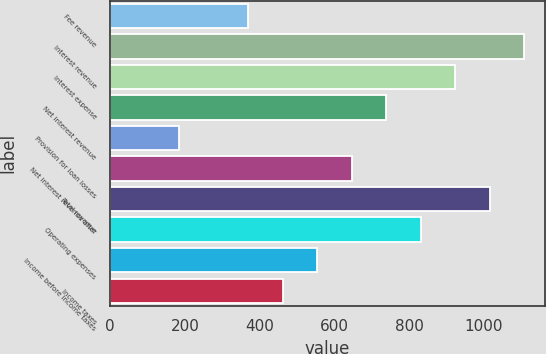Convert chart to OTSL. <chart><loc_0><loc_0><loc_500><loc_500><bar_chart><fcel>Fee revenue<fcel>Interest revenue<fcel>Interest expense<fcel>Net interest revenue<fcel>Provision for loan losses<fcel>Net interest revenue after<fcel>Total revenue<fcel>Operating expenses<fcel>Income before income taxes<fcel>Income taxes<nl><fcel>369.88<fcel>1108.73<fcel>924.03<fcel>739.32<fcel>185.17<fcel>646.96<fcel>1016.38<fcel>831.68<fcel>554.6<fcel>462.24<nl></chart> 